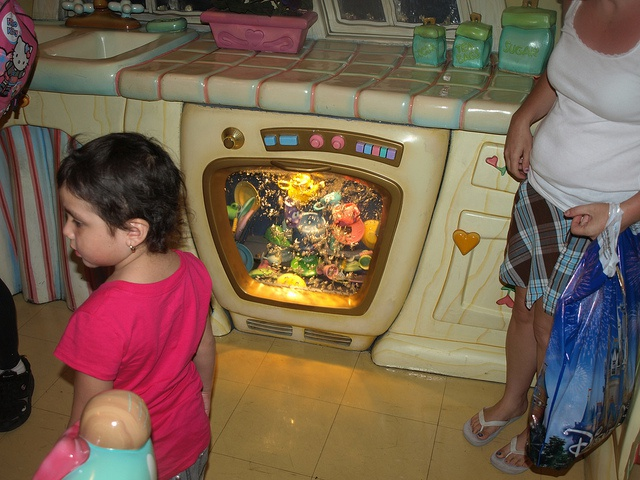Describe the objects in this image and their specific colors. I can see oven in brown, tan, olive, and maroon tones, people in brown, darkgray, gray, and maroon tones, people in brown and black tones, backpack in brown, navy, black, and gray tones, and handbag in brown, navy, black, and gray tones in this image. 